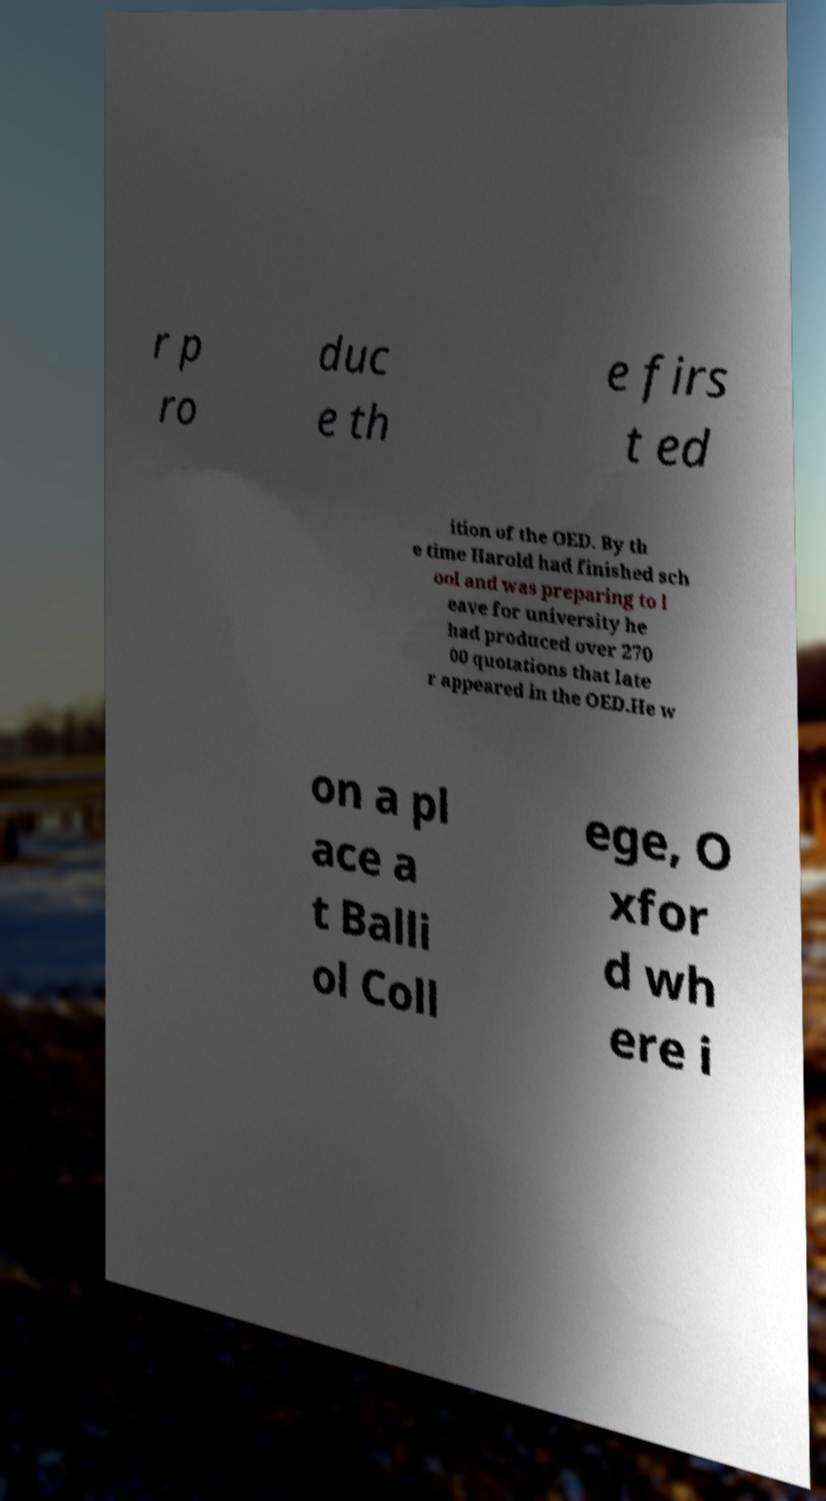What messages or text are displayed in this image? I need them in a readable, typed format. r p ro duc e th e firs t ed ition of the OED. By th e time Harold had finished sch ool and was preparing to l eave for university he had produced over 270 00 quotations that late r appeared in the OED.He w on a pl ace a t Balli ol Coll ege, O xfor d wh ere i 